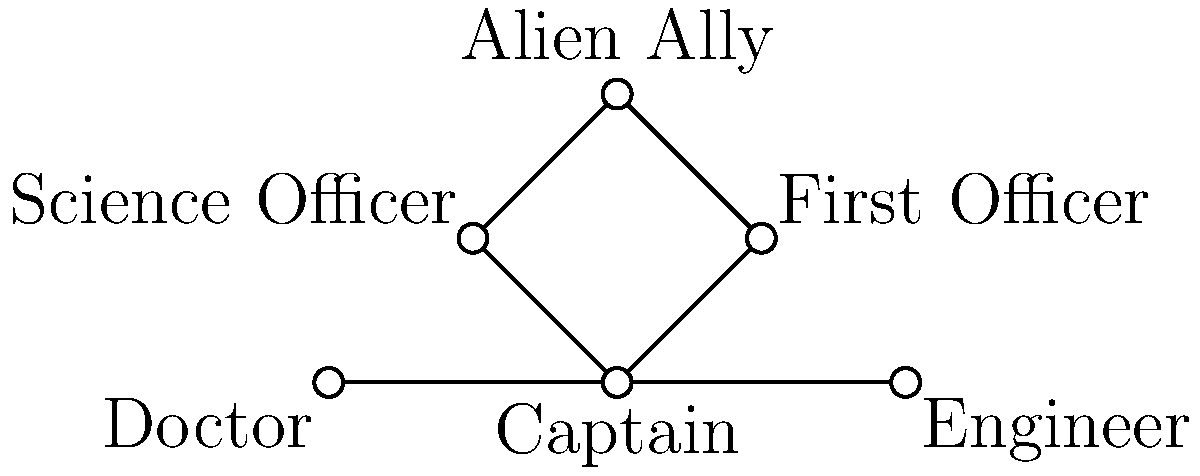In the social network graph of a classic 1960s-inspired sci-fi storyline, which character acts as the central hub, connecting most of the other characters directly? To determine the central hub in this social network graph, we need to analyze the connections (edges) between characters (vertices). Let's break it down step-by-step:

1. Count the number of direct connections for each character:
   - Captain: 4 connections (First Officer, Science Officer, Engineer, Doctor)
   - First Officer: 2 connections (Captain, Alien Ally)
   - Science Officer: 2 connections (Captain, Alien Ally)
   - Alien Ally: 2 connections (First Officer, Science Officer)
   - Engineer: 2 connections (Captain, Doctor)
   - Doctor: 2 connections (Captain, Engineer)

2. Identify the character with the most direct connections:
   The Captain has 4 direct connections, while all other characters have 2 connections each.

3. Analyze the structure of the graph:
   The Captain is positioned at the center of the graph, with direct links to 4 out of 5 other characters.

4. Consider the implications for the storyline:
   This structure suggests that the Captain is the main character through whom most of the interactions and plot developments are likely to flow, which is typical in classic 1960s sci-fi shows.

Based on this analysis, we can conclude that the Captain acts as the central hub in this social network graph, connecting most of the other characters directly.
Answer: Captain 